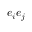Convert formula to latex. <formula><loc_0><loc_0><loc_500><loc_500>e _ { i } e _ { j }</formula> 